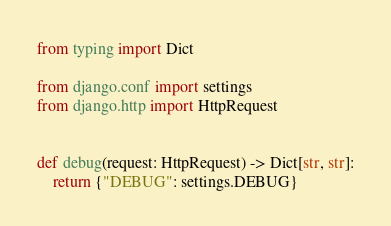Convert code to text. <code><loc_0><loc_0><loc_500><loc_500><_Python_>from typing import Dict

from django.conf import settings
from django.http import HttpRequest


def debug(request: HttpRequest) -> Dict[str, str]:
    return {"DEBUG": settings.DEBUG}
</code> 